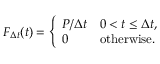<formula> <loc_0><loc_0><loc_500><loc_500>F _ { \Delta t } ( t ) = { \left \{ \begin{array} { l l } { P / \Delta t } & { 0 < t \leq \Delta t , } \\ { 0 } & { { o t h e r w i s e } . } \end{array} }</formula> 